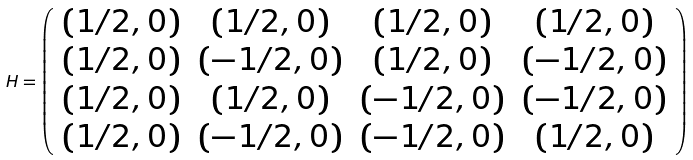Convert formula to latex. <formula><loc_0><loc_0><loc_500><loc_500>H = \left ( \begin{array} { c c c c } ( 1 / 2 , 0 ) & ( 1 / 2 , 0 ) & ( 1 / 2 , 0 ) & ( 1 / 2 , 0 ) \\ ( 1 / 2 , 0 ) & ( - 1 / 2 , 0 ) & ( 1 / 2 , 0 ) & ( - 1 / 2 , 0 ) \\ ( 1 / 2 , 0 ) & ( 1 / 2 , 0 ) & ( - 1 / 2 , 0 ) & ( - 1 / 2 , 0 ) \\ ( 1 / 2 , 0 ) & ( - 1 / 2 , 0 ) & ( - 1 / 2 , 0 ) & ( 1 / 2 , 0 ) \end{array} \right )</formula> 